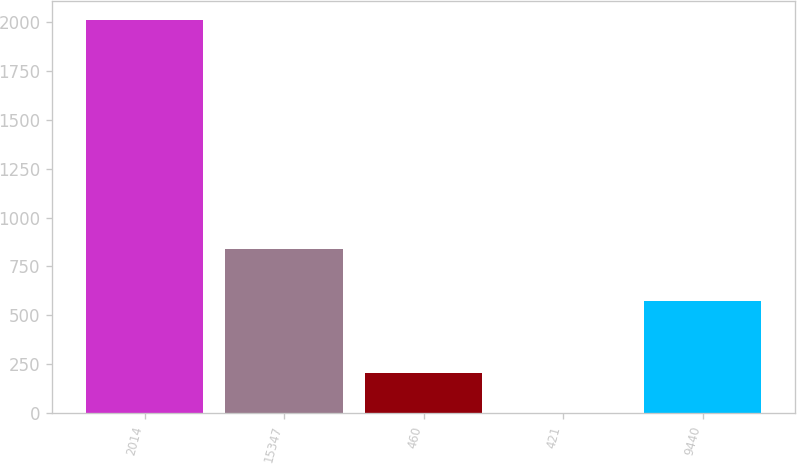<chart> <loc_0><loc_0><loc_500><loc_500><bar_chart><fcel>2014<fcel>15347<fcel>460<fcel>421<fcel>9440<nl><fcel>2010<fcel>839.2<fcel>202.92<fcel>2.13<fcel>574.3<nl></chart> 